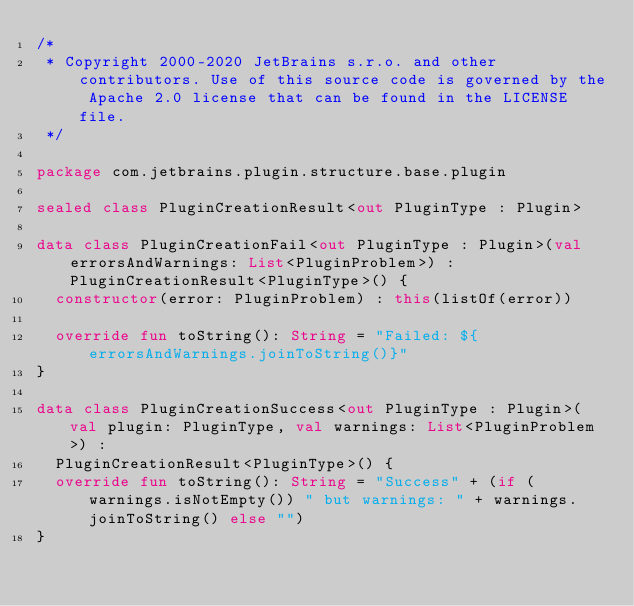Convert code to text. <code><loc_0><loc_0><loc_500><loc_500><_Kotlin_>/*
 * Copyright 2000-2020 JetBrains s.r.o. and other contributors. Use of this source code is governed by the Apache 2.0 license that can be found in the LICENSE file.
 */

package com.jetbrains.plugin.structure.base.plugin

sealed class PluginCreationResult<out PluginType : Plugin>

data class PluginCreationFail<out PluginType : Plugin>(val errorsAndWarnings: List<PluginProblem>) : PluginCreationResult<PluginType>() {
  constructor(error: PluginProblem) : this(listOf(error))

  override fun toString(): String = "Failed: ${errorsAndWarnings.joinToString()}"
}

data class PluginCreationSuccess<out PluginType : Plugin>(val plugin: PluginType, val warnings: List<PluginProblem>) :
  PluginCreationResult<PluginType>() {
  override fun toString(): String = "Success" + (if (warnings.isNotEmpty()) " but warnings: " + warnings.joinToString() else "")
}</code> 